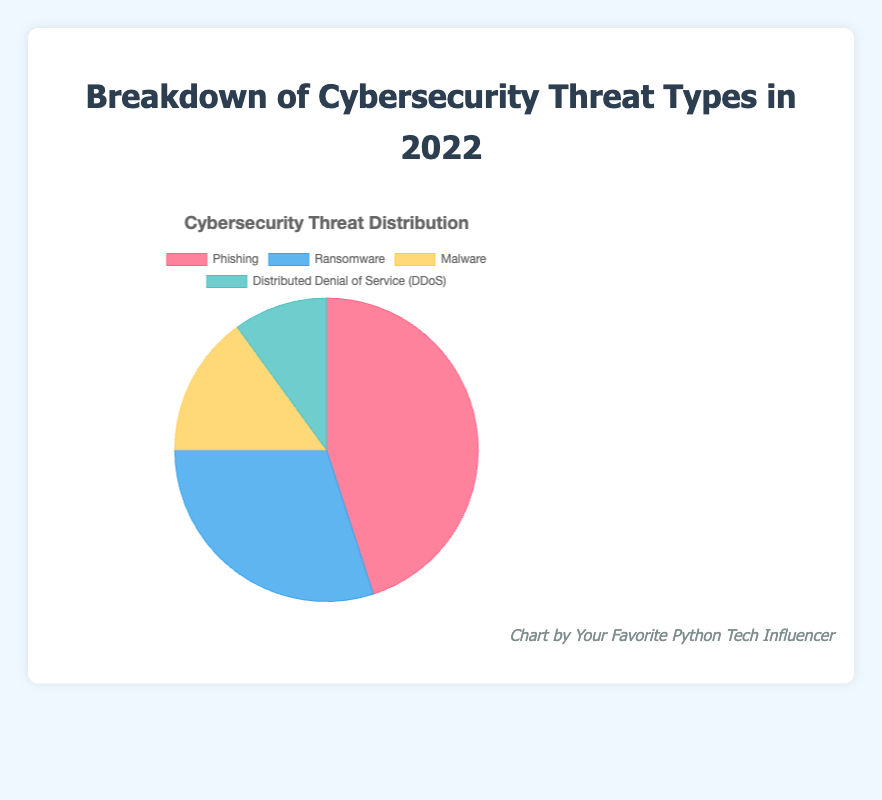Which cybersecurity threat type had the highest percentage in 2022? The pie chart shows the distribution of cybersecurity threat types with their respective percentages. By visual inspection, Phishing has the highest percentage at 45%.
Answer: Phishing Which threat type had the lowest percentage? By visual inspection of the pie chart, Distributed Denial of Service (DDoS) has the smallest segment, representing 10%.
Answer: Distributed Denial of Service (DDoS) How much larger is the percentage of Phishing attacks compared to Ransomware attacks? The percentage for Phishing is 45%, and for Ransomware, it is 30%. The difference is calculated as 45% - 30% = 15%.
Answer: 15% What is the combined percentage of Malware and DDoS attacks? The percentage for Malware is 15%, and for DDoS, it is 10%. The combined percentage is calculated as 15% + 10% = 25%.
Answer: 25% What is the second most common cybersecurity threat type in 2022? By visual inspection, after Phishing (45%), the next largest segment is Ransomware at 30%.
Answer: Ransomware What percentage of the total threats are not phishing? Phishing constitutes 45%, so the remaining percentage is calculated as 100% - 45% = 55%.
Answer: 55% Which two threat types combined equal the percentage of Phishing attacks? The percentage for Phishing is 45%. The combined percentage of Ransomware (30%) and Malware (15%) equals 30% + 15% = 45%.
Answer: Ransomware and Malware How does the prevalence of Malware compare to that of Ransomware? The pie chart shows Malware at 15% and Ransomware at 30%. Ransomware is twice as prevalent as Malware.
Answer: Ransomware is twice as prevalent as Malware If the total count of cybersecurity incidents was 2000 in 2022, how many incidents were due to DDoS? DDoS accounts for 10% of the total incidents. Therefore, the number of DDoS incidents is calculated as 10% of 2000, which is 0.10 * 2000 = 200.
Answer: 200 What color is used to represent the Ransomware threat type in the pie chart? By referencing the pie chart's segment colors, the Ransomware threat type is shown in blue.
Answer: Blue 